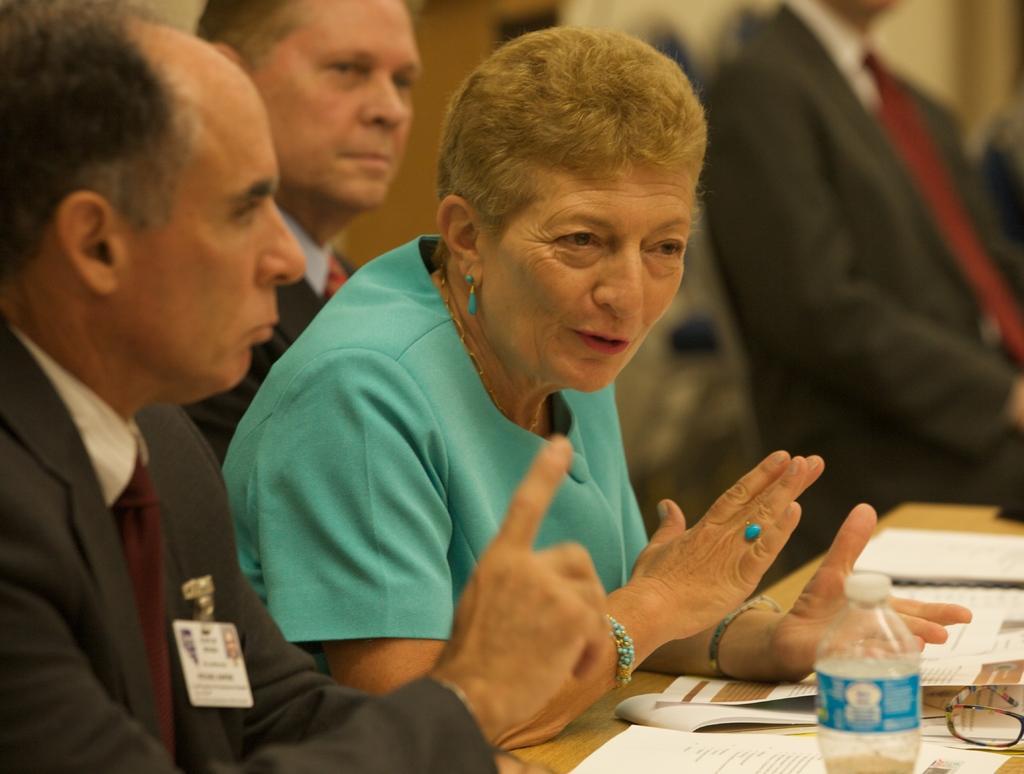Can you describe this image briefly? In this picture we can see three persons are sitting in front of a table, there is a bottle, some papers and spectacles present on the table, in the background we can see another person, there is a blurry background. 